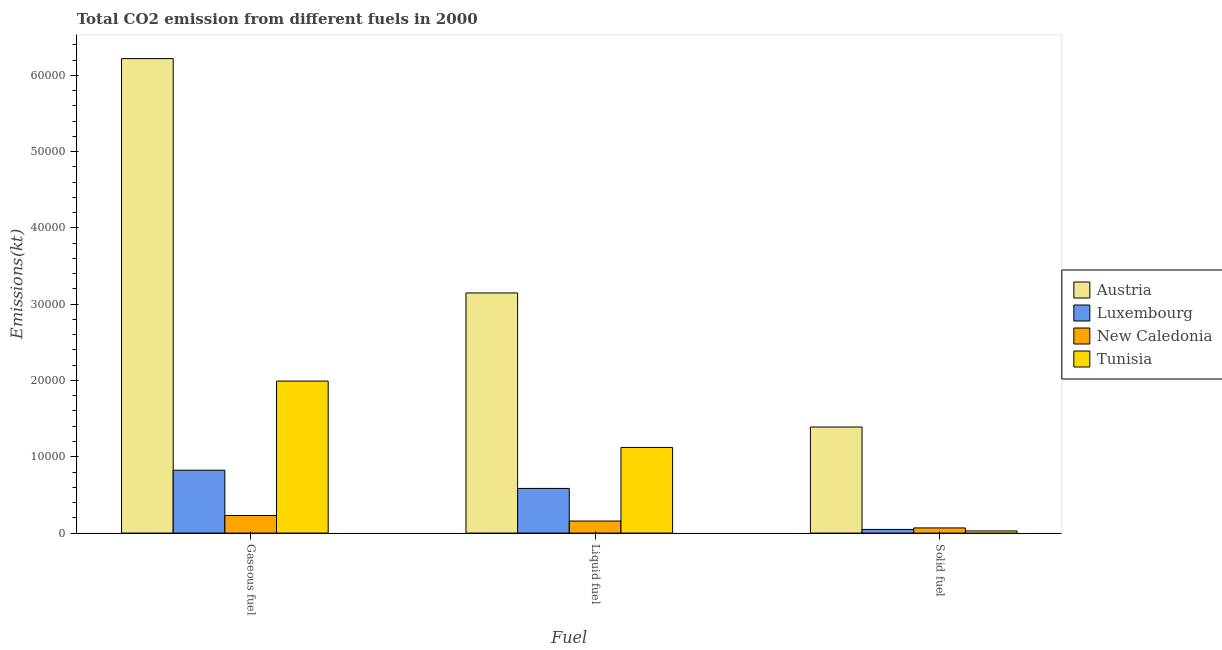How many different coloured bars are there?
Your answer should be compact. 4. How many groups of bars are there?
Give a very brief answer. 3. Are the number of bars on each tick of the X-axis equal?
Give a very brief answer. Yes. How many bars are there on the 3rd tick from the right?
Provide a short and direct response. 4. What is the label of the 1st group of bars from the left?
Your answer should be compact. Gaseous fuel. What is the amount of co2 emissions from gaseous fuel in Luxembourg?
Provide a succinct answer. 8239.75. Across all countries, what is the maximum amount of co2 emissions from solid fuel?
Provide a short and direct response. 1.39e+04. Across all countries, what is the minimum amount of co2 emissions from solid fuel?
Keep it short and to the point. 278.69. In which country was the amount of co2 emissions from solid fuel minimum?
Your answer should be very brief. Tunisia. What is the total amount of co2 emissions from gaseous fuel in the graph?
Offer a very short reply. 9.27e+04. What is the difference between the amount of co2 emissions from solid fuel in Tunisia and that in Luxembourg?
Give a very brief answer. -198.02. What is the difference between the amount of co2 emissions from solid fuel in Austria and the amount of co2 emissions from liquid fuel in New Caledonia?
Your answer should be very brief. 1.23e+04. What is the average amount of co2 emissions from liquid fuel per country?
Your answer should be very brief. 1.25e+04. What is the difference between the amount of co2 emissions from solid fuel and amount of co2 emissions from gaseous fuel in New Caledonia?
Ensure brevity in your answer.  -1624.48. In how many countries, is the amount of co2 emissions from liquid fuel greater than 30000 kt?
Your answer should be compact. 1. What is the ratio of the amount of co2 emissions from liquid fuel in Tunisia to that in Luxembourg?
Provide a short and direct response. 1.92. Is the amount of co2 emissions from gaseous fuel in New Caledonia less than that in Luxembourg?
Keep it short and to the point. Yes. What is the difference between the highest and the second highest amount of co2 emissions from gaseous fuel?
Your answer should be very brief. 4.23e+04. What is the difference between the highest and the lowest amount of co2 emissions from liquid fuel?
Give a very brief answer. 2.99e+04. In how many countries, is the amount of co2 emissions from liquid fuel greater than the average amount of co2 emissions from liquid fuel taken over all countries?
Provide a short and direct response. 1. What does the 2nd bar from the left in Liquid fuel represents?
Your answer should be compact. Luxembourg. What does the 4th bar from the right in Liquid fuel represents?
Offer a terse response. Austria. Is it the case that in every country, the sum of the amount of co2 emissions from gaseous fuel and amount of co2 emissions from liquid fuel is greater than the amount of co2 emissions from solid fuel?
Your response must be concise. Yes. How many bars are there?
Make the answer very short. 12. Are all the bars in the graph horizontal?
Make the answer very short. No. Does the graph contain any zero values?
Give a very brief answer. No. How many legend labels are there?
Your answer should be compact. 4. What is the title of the graph?
Give a very brief answer. Total CO2 emission from different fuels in 2000. What is the label or title of the X-axis?
Your answer should be very brief. Fuel. What is the label or title of the Y-axis?
Your answer should be compact. Emissions(kt). What is the Emissions(kt) of Austria in Gaseous fuel?
Your answer should be compact. 6.22e+04. What is the Emissions(kt) in Luxembourg in Gaseous fuel?
Keep it short and to the point. 8239.75. What is the Emissions(kt) in New Caledonia in Gaseous fuel?
Offer a very short reply. 2299.21. What is the Emissions(kt) in Tunisia in Gaseous fuel?
Ensure brevity in your answer.  1.99e+04. What is the Emissions(kt) of Austria in Liquid fuel?
Provide a succinct answer. 3.15e+04. What is the Emissions(kt) of Luxembourg in Liquid fuel?
Ensure brevity in your answer.  5852.53. What is the Emissions(kt) of New Caledonia in Liquid fuel?
Your answer should be very brief. 1576.81. What is the Emissions(kt) of Tunisia in Liquid fuel?
Ensure brevity in your answer.  1.12e+04. What is the Emissions(kt) in Austria in Solid fuel?
Keep it short and to the point. 1.39e+04. What is the Emissions(kt) of Luxembourg in Solid fuel?
Ensure brevity in your answer.  476.71. What is the Emissions(kt) of New Caledonia in Solid fuel?
Provide a short and direct response. 674.73. What is the Emissions(kt) of Tunisia in Solid fuel?
Offer a terse response. 278.69. Across all Fuel, what is the maximum Emissions(kt) in Austria?
Offer a terse response. 6.22e+04. Across all Fuel, what is the maximum Emissions(kt) in Luxembourg?
Ensure brevity in your answer.  8239.75. Across all Fuel, what is the maximum Emissions(kt) of New Caledonia?
Your response must be concise. 2299.21. Across all Fuel, what is the maximum Emissions(kt) in Tunisia?
Provide a succinct answer. 1.99e+04. Across all Fuel, what is the minimum Emissions(kt) in Austria?
Your answer should be compact. 1.39e+04. Across all Fuel, what is the minimum Emissions(kt) in Luxembourg?
Make the answer very short. 476.71. Across all Fuel, what is the minimum Emissions(kt) in New Caledonia?
Offer a terse response. 674.73. Across all Fuel, what is the minimum Emissions(kt) in Tunisia?
Make the answer very short. 278.69. What is the total Emissions(kt) in Austria in the graph?
Keep it short and to the point. 1.08e+05. What is the total Emissions(kt) in Luxembourg in the graph?
Your answer should be very brief. 1.46e+04. What is the total Emissions(kt) in New Caledonia in the graph?
Your answer should be very brief. 4550.75. What is the total Emissions(kt) of Tunisia in the graph?
Ensure brevity in your answer.  3.14e+04. What is the difference between the Emissions(kt) of Austria in Gaseous fuel and that in Liquid fuel?
Provide a succinct answer. 3.07e+04. What is the difference between the Emissions(kt) of Luxembourg in Gaseous fuel and that in Liquid fuel?
Offer a terse response. 2387.22. What is the difference between the Emissions(kt) in New Caledonia in Gaseous fuel and that in Liquid fuel?
Your answer should be very brief. 722.4. What is the difference between the Emissions(kt) in Tunisia in Gaseous fuel and that in Liquid fuel?
Your answer should be compact. 8698.12. What is the difference between the Emissions(kt) of Austria in Gaseous fuel and that in Solid fuel?
Provide a short and direct response. 4.83e+04. What is the difference between the Emissions(kt) in Luxembourg in Gaseous fuel and that in Solid fuel?
Keep it short and to the point. 7763.04. What is the difference between the Emissions(kt) in New Caledonia in Gaseous fuel and that in Solid fuel?
Your answer should be very brief. 1624.48. What is the difference between the Emissions(kt) in Tunisia in Gaseous fuel and that in Solid fuel?
Keep it short and to the point. 1.96e+04. What is the difference between the Emissions(kt) of Austria in Liquid fuel and that in Solid fuel?
Offer a terse response. 1.76e+04. What is the difference between the Emissions(kt) of Luxembourg in Liquid fuel and that in Solid fuel?
Provide a short and direct response. 5375.82. What is the difference between the Emissions(kt) in New Caledonia in Liquid fuel and that in Solid fuel?
Provide a short and direct response. 902.08. What is the difference between the Emissions(kt) of Tunisia in Liquid fuel and that in Solid fuel?
Make the answer very short. 1.09e+04. What is the difference between the Emissions(kt) in Austria in Gaseous fuel and the Emissions(kt) in Luxembourg in Liquid fuel?
Your response must be concise. 5.63e+04. What is the difference between the Emissions(kt) of Austria in Gaseous fuel and the Emissions(kt) of New Caledonia in Liquid fuel?
Offer a very short reply. 6.06e+04. What is the difference between the Emissions(kt) in Austria in Gaseous fuel and the Emissions(kt) in Tunisia in Liquid fuel?
Offer a very short reply. 5.10e+04. What is the difference between the Emissions(kt) of Luxembourg in Gaseous fuel and the Emissions(kt) of New Caledonia in Liquid fuel?
Offer a terse response. 6662.94. What is the difference between the Emissions(kt) of Luxembourg in Gaseous fuel and the Emissions(kt) of Tunisia in Liquid fuel?
Your answer should be very brief. -2984.94. What is the difference between the Emissions(kt) of New Caledonia in Gaseous fuel and the Emissions(kt) of Tunisia in Liquid fuel?
Make the answer very short. -8925.48. What is the difference between the Emissions(kt) of Austria in Gaseous fuel and the Emissions(kt) of Luxembourg in Solid fuel?
Offer a terse response. 6.17e+04. What is the difference between the Emissions(kt) in Austria in Gaseous fuel and the Emissions(kt) in New Caledonia in Solid fuel?
Ensure brevity in your answer.  6.15e+04. What is the difference between the Emissions(kt) in Austria in Gaseous fuel and the Emissions(kt) in Tunisia in Solid fuel?
Your response must be concise. 6.19e+04. What is the difference between the Emissions(kt) in Luxembourg in Gaseous fuel and the Emissions(kt) in New Caledonia in Solid fuel?
Ensure brevity in your answer.  7565.02. What is the difference between the Emissions(kt) in Luxembourg in Gaseous fuel and the Emissions(kt) in Tunisia in Solid fuel?
Offer a terse response. 7961.06. What is the difference between the Emissions(kt) in New Caledonia in Gaseous fuel and the Emissions(kt) in Tunisia in Solid fuel?
Your answer should be compact. 2020.52. What is the difference between the Emissions(kt) in Austria in Liquid fuel and the Emissions(kt) in Luxembourg in Solid fuel?
Provide a short and direct response. 3.10e+04. What is the difference between the Emissions(kt) in Austria in Liquid fuel and the Emissions(kt) in New Caledonia in Solid fuel?
Ensure brevity in your answer.  3.08e+04. What is the difference between the Emissions(kt) in Austria in Liquid fuel and the Emissions(kt) in Tunisia in Solid fuel?
Provide a short and direct response. 3.12e+04. What is the difference between the Emissions(kt) in Luxembourg in Liquid fuel and the Emissions(kt) in New Caledonia in Solid fuel?
Provide a short and direct response. 5177.8. What is the difference between the Emissions(kt) in Luxembourg in Liquid fuel and the Emissions(kt) in Tunisia in Solid fuel?
Your answer should be compact. 5573.84. What is the difference between the Emissions(kt) of New Caledonia in Liquid fuel and the Emissions(kt) of Tunisia in Solid fuel?
Provide a succinct answer. 1298.12. What is the average Emissions(kt) in Austria per Fuel?
Your answer should be very brief. 3.59e+04. What is the average Emissions(kt) in Luxembourg per Fuel?
Offer a very short reply. 4856.33. What is the average Emissions(kt) in New Caledonia per Fuel?
Give a very brief answer. 1516.92. What is the average Emissions(kt) in Tunisia per Fuel?
Offer a terse response. 1.05e+04. What is the difference between the Emissions(kt) in Austria and Emissions(kt) in Luxembourg in Gaseous fuel?
Your answer should be compact. 5.39e+04. What is the difference between the Emissions(kt) in Austria and Emissions(kt) in New Caledonia in Gaseous fuel?
Offer a very short reply. 5.99e+04. What is the difference between the Emissions(kt) of Austria and Emissions(kt) of Tunisia in Gaseous fuel?
Provide a succinct answer. 4.23e+04. What is the difference between the Emissions(kt) in Luxembourg and Emissions(kt) in New Caledonia in Gaseous fuel?
Provide a short and direct response. 5940.54. What is the difference between the Emissions(kt) of Luxembourg and Emissions(kt) of Tunisia in Gaseous fuel?
Your answer should be compact. -1.17e+04. What is the difference between the Emissions(kt) in New Caledonia and Emissions(kt) in Tunisia in Gaseous fuel?
Make the answer very short. -1.76e+04. What is the difference between the Emissions(kt) in Austria and Emissions(kt) in Luxembourg in Liquid fuel?
Provide a succinct answer. 2.56e+04. What is the difference between the Emissions(kt) of Austria and Emissions(kt) of New Caledonia in Liquid fuel?
Your answer should be compact. 2.99e+04. What is the difference between the Emissions(kt) of Austria and Emissions(kt) of Tunisia in Liquid fuel?
Make the answer very short. 2.02e+04. What is the difference between the Emissions(kt) in Luxembourg and Emissions(kt) in New Caledonia in Liquid fuel?
Offer a very short reply. 4275.72. What is the difference between the Emissions(kt) in Luxembourg and Emissions(kt) in Tunisia in Liquid fuel?
Give a very brief answer. -5372.15. What is the difference between the Emissions(kt) of New Caledonia and Emissions(kt) of Tunisia in Liquid fuel?
Make the answer very short. -9647.88. What is the difference between the Emissions(kt) of Austria and Emissions(kt) of Luxembourg in Solid fuel?
Keep it short and to the point. 1.34e+04. What is the difference between the Emissions(kt) of Austria and Emissions(kt) of New Caledonia in Solid fuel?
Provide a short and direct response. 1.32e+04. What is the difference between the Emissions(kt) in Austria and Emissions(kt) in Tunisia in Solid fuel?
Provide a succinct answer. 1.36e+04. What is the difference between the Emissions(kt) in Luxembourg and Emissions(kt) in New Caledonia in Solid fuel?
Provide a short and direct response. -198.02. What is the difference between the Emissions(kt) of Luxembourg and Emissions(kt) of Tunisia in Solid fuel?
Offer a very short reply. 198.02. What is the difference between the Emissions(kt) of New Caledonia and Emissions(kt) of Tunisia in Solid fuel?
Provide a short and direct response. 396.04. What is the ratio of the Emissions(kt) in Austria in Gaseous fuel to that in Liquid fuel?
Your response must be concise. 1.98. What is the ratio of the Emissions(kt) of Luxembourg in Gaseous fuel to that in Liquid fuel?
Make the answer very short. 1.41. What is the ratio of the Emissions(kt) in New Caledonia in Gaseous fuel to that in Liquid fuel?
Provide a succinct answer. 1.46. What is the ratio of the Emissions(kt) in Tunisia in Gaseous fuel to that in Liquid fuel?
Provide a succinct answer. 1.77. What is the ratio of the Emissions(kt) in Austria in Gaseous fuel to that in Solid fuel?
Provide a short and direct response. 4.47. What is the ratio of the Emissions(kt) in Luxembourg in Gaseous fuel to that in Solid fuel?
Give a very brief answer. 17.28. What is the ratio of the Emissions(kt) in New Caledonia in Gaseous fuel to that in Solid fuel?
Provide a succinct answer. 3.41. What is the ratio of the Emissions(kt) in Tunisia in Gaseous fuel to that in Solid fuel?
Your answer should be very brief. 71.49. What is the ratio of the Emissions(kt) of Austria in Liquid fuel to that in Solid fuel?
Your response must be concise. 2.26. What is the ratio of the Emissions(kt) in Luxembourg in Liquid fuel to that in Solid fuel?
Provide a short and direct response. 12.28. What is the ratio of the Emissions(kt) of New Caledonia in Liquid fuel to that in Solid fuel?
Your response must be concise. 2.34. What is the ratio of the Emissions(kt) of Tunisia in Liquid fuel to that in Solid fuel?
Keep it short and to the point. 40.28. What is the difference between the highest and the second highest Emissions(kt) in Austria?
Provide a short and direct response. 3.07e+04. What is the difference between the highest and the second highest Emissions(kt) of Luxembourg?
Ensure brevity in your answer.  2387.22. What is the difference between the highest and the second highest Emissions(kt) in New Caledonia?
Offer a terse response. 722.4. What is the difference between the highest and the second highest Emissions(kt) of Tunisia?
Give a very brief answer. 8698.12. What is the difference between the highest and the lowest Emissions(kt) in Austria?
Make the answer very short. 4.83e+04. What is the difference between the highest and the lowest Emissions(kt) of Luxembourg?
Offer a very short reply. 7763.04. What is the difference between the highest and the lowest Emissions(kt) of New Caledonia?
Make the answer very short. 1624.48. What is the difference between the highest and the lowest Emissions(kt) in Tunisia?
Your response must be concise. 1.96e+04. 